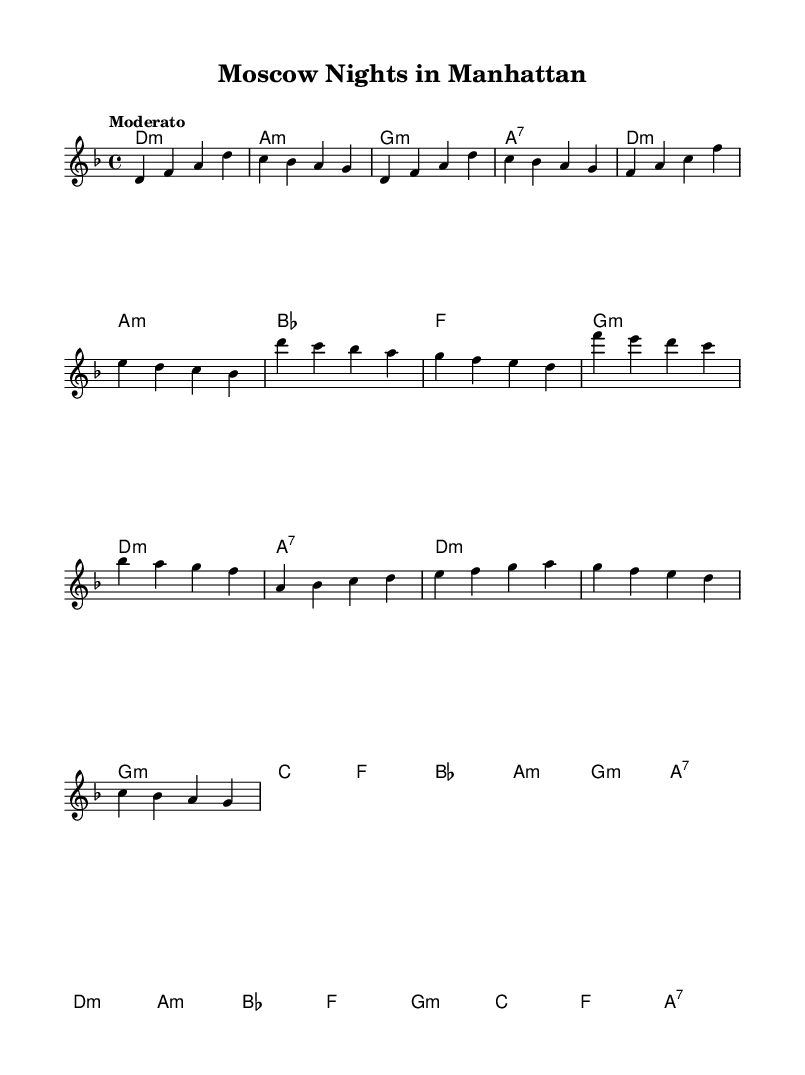What is the key signature of this music? The key signature is indicated at the beginning of the score. It shows two flats, which corresponds to the key of D minor.
Answer: D minor What is the time signature of this piece? The time signature is located at the beginning of the score, shown as a "4/4", indicating that there are four beats in each measure.
Answer: 4/4 What is the tempo marking of this music? The tempo marking is indicated in the score as "Moderato," which describes the speed of play.
Answer: Moderato How many sections are there in the structure of the music? The score consists of an intro, verse, chorus, and bridge, totaling four distinct sections.
Answer: Four Which chord is played in the introduction? By examining the chord names at the beginning of the score, the first chord listed is D minor.
Answer: D minor What is the last chord in the bridge section? The last chord in the bridge is identified within the chord progression for that section; it shows A7 as the last chord.
Answer: A7 